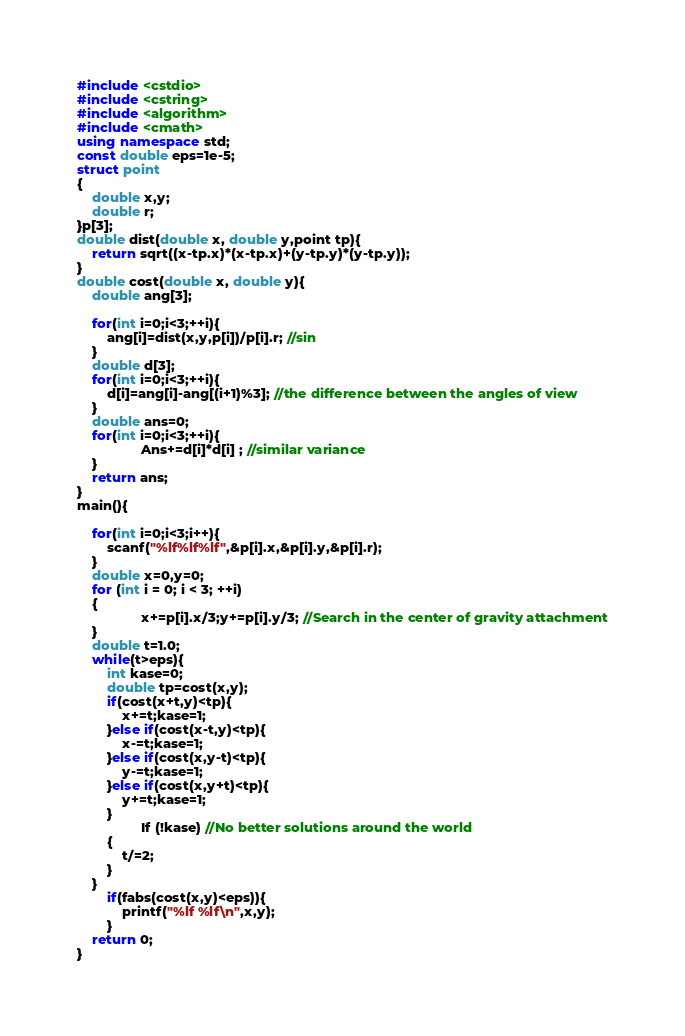<code> <loc_0><loc_0><loc_500><loc_500><_C++_>#include <cstdio>
#include <cstring>
#include <algorithm>
#include <cmath>
using namespace std;
const double eps=1e-5;
struct point
{
    double x,y;
    double r;
}p[3];
double dist(double x, double y,point tp){
    return sqrt((x-tp.x)*(x-tp.x)+(y-tp.y)*(y-tp.y));
}
double cost(double x, double y){
    double ang[3];

    for(int i=0;i<3;++i){
        ang[i]=dist(x,y,p[i])/p[i].r; //sin
    }
    double d[3];
    for(int i=0;i<3;++i){
        d[i]=ang[i]-ang[(i+1)%3]; //the difference between the angles of view
    }
    double ans=0;
    for(int i=0;i<3;++i){
                 Ans+=d[i]*d[i] ; //similar variance
    }
    return ans;
}
main(){

    for(int i=0;i<3;i++){
        scanf("%lf%lf%lf",&p[i].x,&p[i].y,&p[i].r);
    }
    double x=0,y=0;
    for (int i = 0; i < 3; ++i)
    {
                 x+=p[i].x/3;y+=p[i].y/3; //Search in the center of gravity attachment
    }
    double t=1.0;
    while(t>eps){
        int kase=0;
        double tp=cost(x,y);
        if(cost(x+t,y)<tp){
            x+=t;kase=1;
        }else if(cost(x-t,y)<tp){
            x-=t;kase=1;
        }else if(cost(x,y-t)<tp){
            y-=t;kase=1;
        }else if(cost(x,y+t)<tp){
            y+=t;kase=1;
        }
                 If (!kase) //No better solutions around the world
        {
            t/=2;
        }
    }
        if(fabs(cost(x,y)<eps)){
            printf("%lf %lf\n",x,y);
        }
    return 0;
}
</code> 